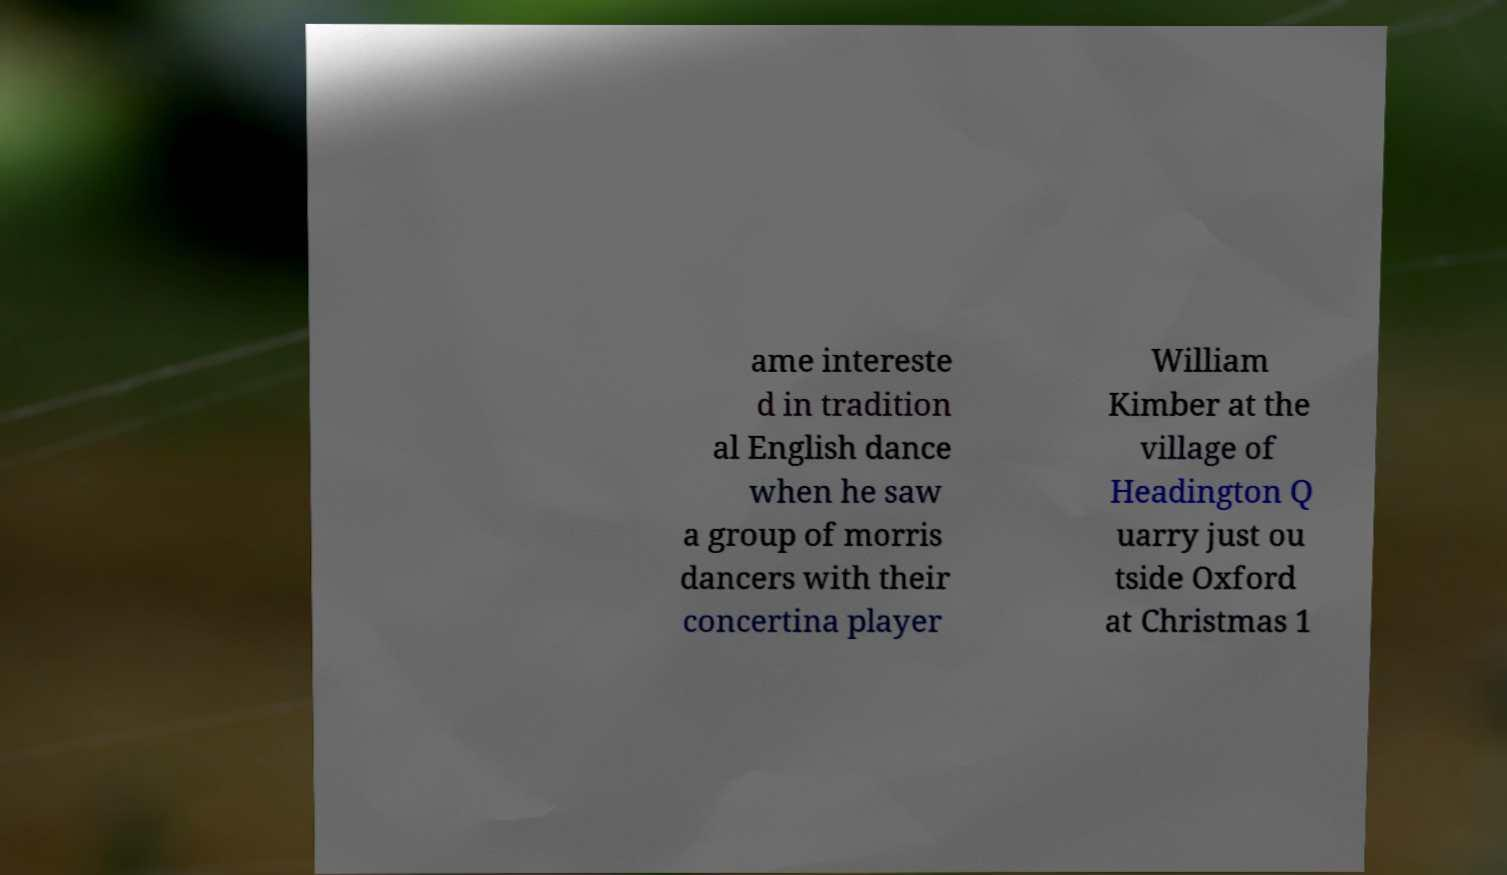Can you read and provide the text displayed in the image?This photo seems to have some interesting text. Can you extract and type it out for me? ame intereste d in tradition al English dance when he saw a group of morris dancers with their concertina player William Kimber at the village of Headington Q uarry just ou tside Oxford at Christmas 1 